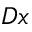<formula> <loc_0><loc_0><loc_500><loc_500>D x</formula> 